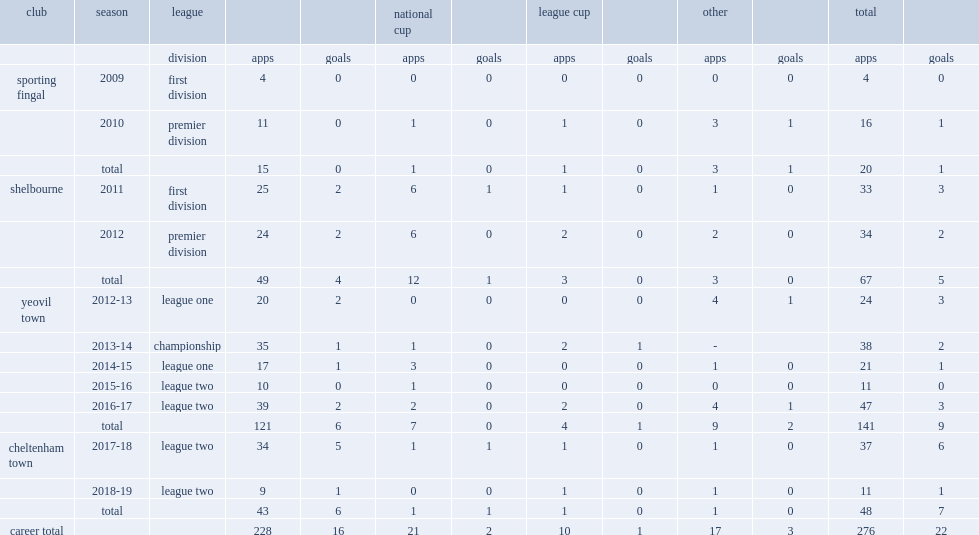In the 2010 premier division, how many league and cup appearances did kevin dawson make? 16.0. 